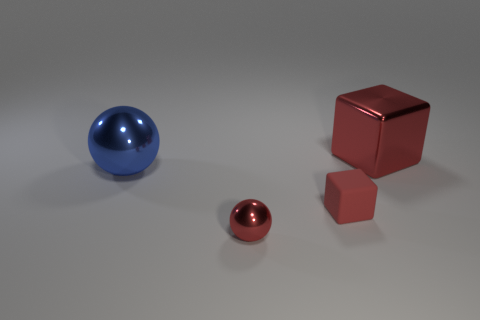Add 2 small shiny balls. How many objects exist? 6 Subtract all big shiny things. Subtract all blue balls. How many objects are left? 1 Add 4 blue metallic objects. How many blue metallic objects are left? 5 Add 2 blue metallic balls. How many blue metallic balls exist? 3 Subtract 0 purple spheres. How many objects are left? 4 